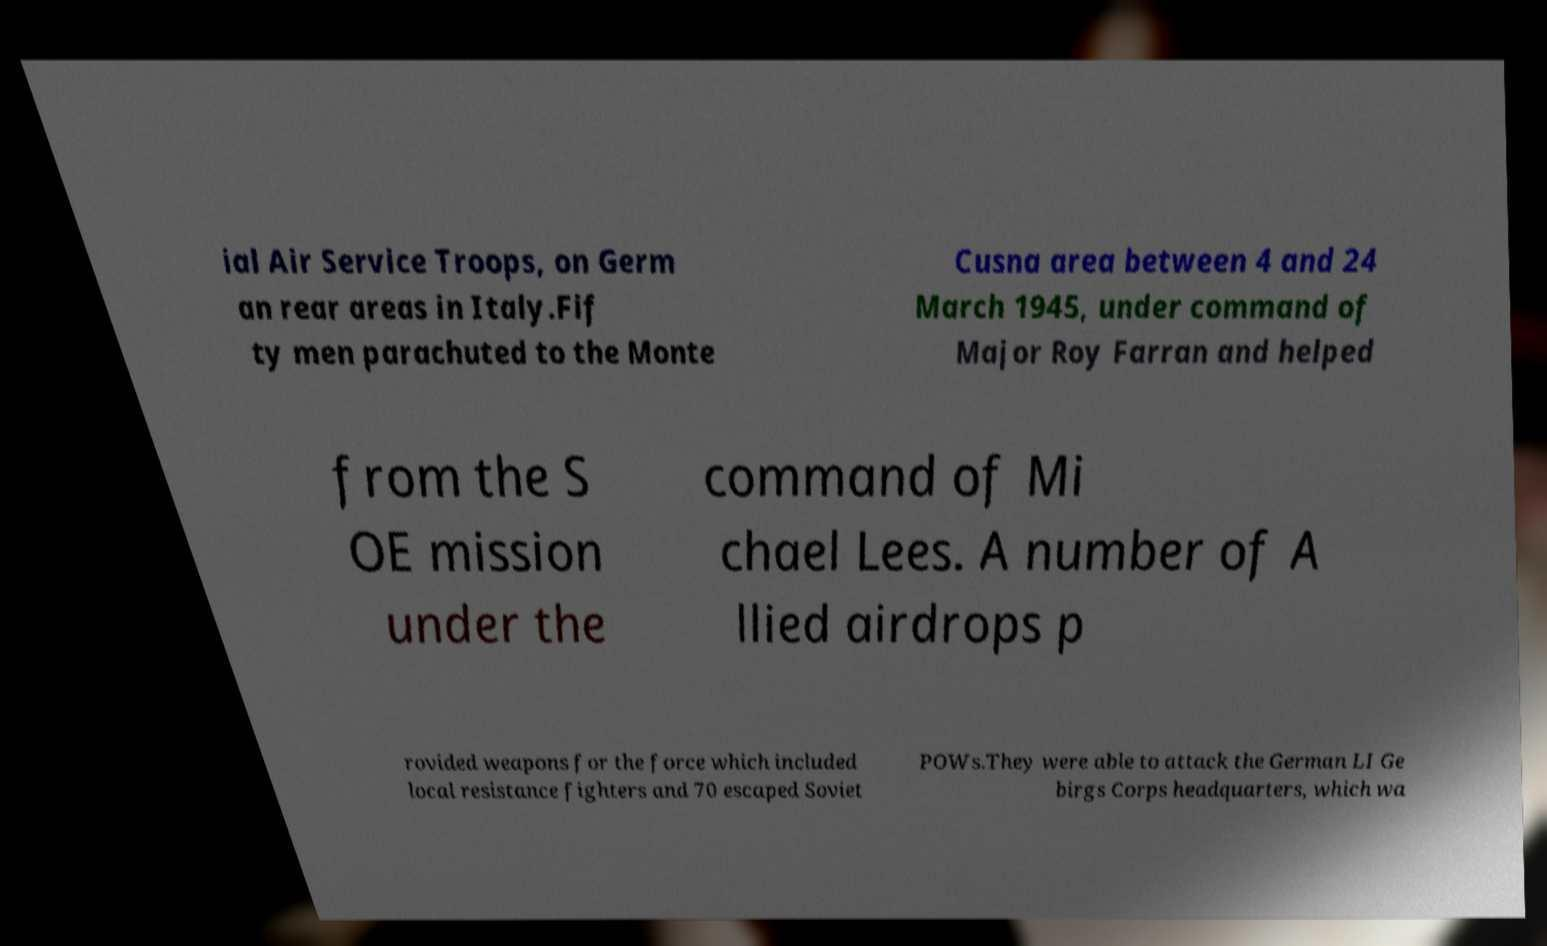What messages or text are displayed in this image? I need them in a readable, typed format. ial Air Service Troops, on Germ an rear areas in Italy.Fif ty men parachuted to the Monte Cusna area between 4 and 24 March 1945, under command of Major Roy Farran and helped from the S OE mission under the command of Mi chael Lees. A number of A llied airdrops p rovided weapons for the force which included local resistance fighters and 70 escaped Soviet POWs.They were able to attack the German LI Ge birgs Corps headquarters, which wa 